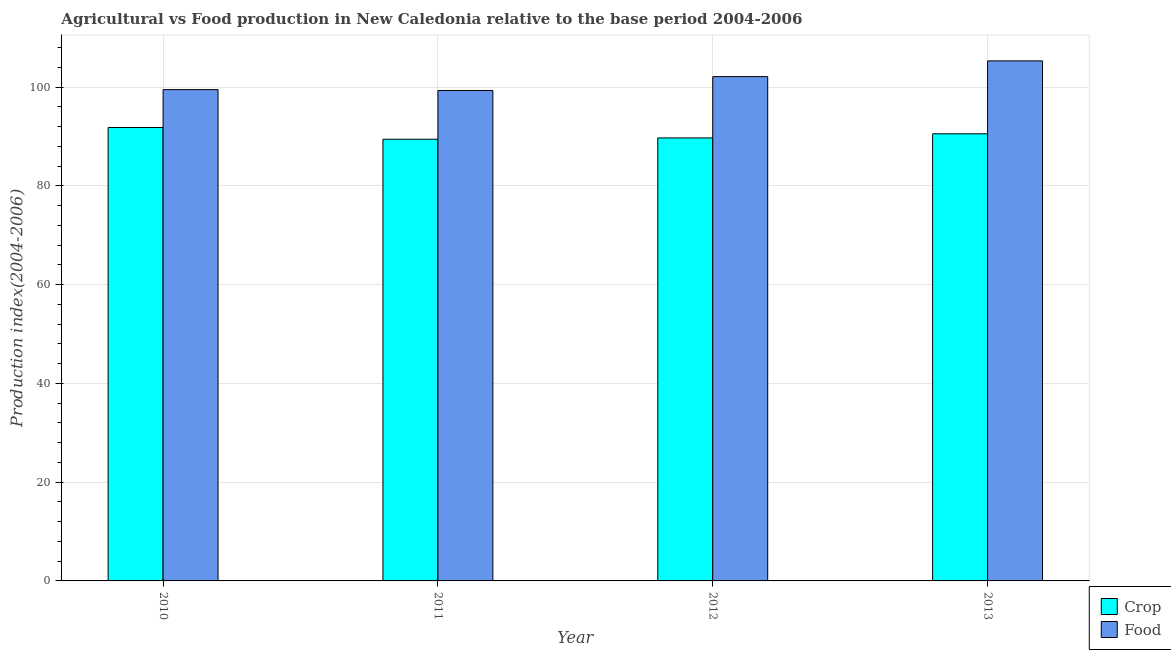How many different coloured bars are there?
Your answer should be compact. 2. Are the number of bars per tick equal to the number of legend labels?
Your response must be concise. Yes. Are the number of bars on each tick of the X-axis equal?
Offer a very short reply. Yes. What is the food production index in 2011?
Give a very brief answer. 99.34. Across all years, what is the maximum crop production index?
Make the answer very short. 91.85. Across all years, what is the minimum crop production index?
Make the answer very short. 89.47. In which year was the crop production index maximum?
Your answer should be compact. 2010. In which year was the crop production index minimum?
Make the answer very short. 2011. What is the total crop production index in the graph?
Offer a terse response. 361.62. What is the difference between the food production index in 2011 and the crop production index in 2013?
Ensure brevity in your answer.  -6. What is the average crop production index per year?
Ensure brevity in your answer.  90.41. In the year 2010, what is the difference between the food production index and crop production index?
Provide a succinct answer. 0. In how many years, is the crop production index greater than 4?
Offer a very short reply. 4. What is the ratio of the food production index in 2010 to that in 2013?
Your answer should be very brief. 0.94. Is the crop production index in 2011 less than that in 2012?
Ensure brevity in your answer.  Yes. Is the difference between the crop production index in 2012 and 2013 greater than the difference between the food production index in 2012 and 2013?
Keep it short and to the point. No. What is the difference between the highest and the second highest food production index?
Make the answer very short. 3.19. What is the difference between the highest and the lowest food production index?
Offer a very short reply. 6. What does the 1st bar from the left in 2011 represents?
Your answer should be very brief. Crop. What does the 2nd bar from the right in 2011 represents?
Ensure brevity in your answer.  Crop. How many years are there in the graph?
Keep it short and to the point. 4. What is the difference between two consecutive major ticks on the Y-axis?
Offer a very short reply. 20. Does the graph contain grids?
Offer a terse response. Yes. Where does the legend appear in the graph?
Give a very brief answer. Bottom right. How are the legend labels stacked?
Your answer should be very brief. Vertical. What is the title of the graph?
Keep it short and to the point. Agricultural vs Food production in New Caledonia relative to the base period 2004-2006. Does "Netherlands" appear as one of the legend labels in the graph?
Your answer should be very brief. No. What is the label or title of the X-axis?
Give a very brief answer. Year. What is the label or title of the Y-axis?
Give a very brief answer. Production index(2004-2006). What is the Production index(2004-2006) in Crop in 2010?
Your response must be concise. 91.85. What is the Production index(2004-2006) in Food in 2010?
Provide a succinct answer. 99.52. What is the Production index(2004-2006) of Crop in 2011?
Keep it short and to the point. 89.47. What is the Production index(2004-2006) in Food in 2011?
Ensure brevity in your answer.  99.34. What is the Production index(2004-2006) of Crop in 2012?
Offer a very short reply. 89.73. What is the Production index(2004-2006) in Food in 2012?
Your response must be concise. 102.15. What is the Production index(2004-2006) of Crop in 2013?
Your answer should be very brief. 90.57. What is the Production index(2004-2006) of Food in 2013?
Your answer should be compact. 105.34. Across all years, what is the maximum Production index(2004-2006) in Crop?
Provide a succinct answer. 91.85. Across all years, what is the maximum Production index(2004-2006) in Food?
Make the answer very short. 105.34. Across all years, what is the minimum Production index(2004-2006) of Crop?
Your answer should be compact. 89.47. Across all years, what is the minimum Production index(2004-2006) of Food?
Offer a terse response. 99.34. What is the total Production index(2004-2006) of Crop in the graph?
Offer a terse response. 361.62. What is the total Production index(2004-2006) in Food in the graph?
Make the answer very short. 406.35. What is the difference between the Production index(2004-2006) in Crop in 2010 and that in 2011?
Offer a terse response. 2.38. What is the difference between the Production index(2004-2006) of Food in 2010 and that in 2011?
Provide a short and direct response. 0.18. What is the difference between the Production index(2004-2006) of Crop in 2010 and that in 2012?
Your response must be concise. 2.12. What is the difference between the Production index(2004-2006) in Food in 2010 and that in 2012?
Keep it short and to the point. -2.63. What is the difference between the Production index(2004-2006) of Crop in 2010 and that in 2013?
Offer a very short reply. 1.28. What is the difference between the Production index(2004-2006) of Food in 2010 and that in 2013?
Provide a succinct answer. -5.82. What is the difference between the Production index(2004-2006) in Crop in 2011 and that in 2012?
Give a very brief answer. -0.26. What is the difference between the Production index(2004-2006) of Food in 2011 and that in 2012?
Give a very brief answer. -2.81. What is the difference between the Production index(2004-2006) of Crop in 2012 and that in 2013?
Provide a short and direct response. -0.84. What is the difference between the Production index(2004-2006) of Food in 2012 and that in 2013?
Provide a succinct answer. -3.19. What is the difference between the Production index(2004-2006) in Crop in 2010 and the Production index(2004-2006) in Food in 2011?
Keep it short and to the point. -7.49. What is the difference between the Production index(2004-2006) of Crop in 2010 and the Production index(2004-2006) of Food in 2012?
Keep it short and to the point. -10.3. What is the difference between the Production index(2004-2006) in Crop in 2010 and the Production index(2004-2006) in Food in 2013?
Ensure brevity in your answer.  -13.49. What is the difference between the Production index(2004-2006) in Crop in 2011 and the Production index(2004-2006) in Food in 2012?
Provide a short and direct response. -12.68. What is the difference between the Production index(2004-2006) in Crop in 2011 and the Production index(2004-2006) in Food in 2013?
Ensure brevity in your answer.  -15.87. What is the difference between the Production index(2004-2006) in Crop in 2012 and the Production index(2004-2006) in Food in 2013?
Provide a succinct answer. -15.61. What is the average Production index(2004-2006) of Crop per year?
Your answer should be compact. 90.41. What is the average Production index(2004-2006) in Food per year?
Give a very brief answer. 101.59. In the year 2010, what is the difference between the Production index(2004-2006) of Crop and Production index(2004-2006) of Food?
Your answer should be compact. -7.67. In the year 2011, what is the difference between the Production index(2004-2006) of Crop and Production index(2004-2006) of Food?
Provide a short and direct response. -9.87. In the year 2012, what is the difference between the Production index(2004-2006) of Crop and Production index(2004-2006) of Food?
Offer a very short reply. -12.42. In the year 2013, what is the difference between the Production index(2004-2006) of Crop and Production index(2004-2006) of Food?
Offer a very short reply. -14.77. What is the ratio of the Production index(2004-2006) of Crop in 2010 to that in 2011?
Offer a very short reply. 1.03. What is the ratio of the Production index(2004-2006) of Food in 2010 to that in 2011?
Offer a very short reply. 1. What is the ratio of the Production index(2004-2006) in Crop in 2010 to that in 2012?
Keep it short and to the point. 1.02. What is the ratio of the Production index(2004-2006) in Food in 2010 to that in 2012?
Offer a very short reply. 0.97. What is the ratio of the Production index(2004-2006) of Crop in 2010 to that in 2013?
Provide a short and direct response. 1.01. What is the ratio of the Production index(2004-2006) of Food in 2010 to that in 2013?
Provide a succinct answer. 0.94. What is the ratio of the Production index(2004-2006) of Food in 2011 to that in 2012?
Give a very brief answer. 0.97. What is the ratio of the Production index(2004-2006) of Crop in 2011 to that in 2013?
Offer a very short reply. 0.99. What is the ratio of the Production index(2004-2006) of Food in 2011 to that in 2013?
Make the answer very short. 0.94. What is the ratio of the Production index(2004-2006) in Food in 2012 to that in 2013?
Make the answer very short. 0.97. What is the difference between the highest and the second highest Production index(2004-2006) of Crop?
Offer a very short reply. 1.28. What is the difference between the highest and the second highest Production index(2004-2006) in Food?
Provide a succinct answer. 3.19. What is the difference between the highest and the lowest Production index(2004-2006) of Crop?
Give a very brief answer. 2.38. What is the difference between the highest and the lowest Production index(2004-2006) of Food?
Give a very brief answer. 6. 